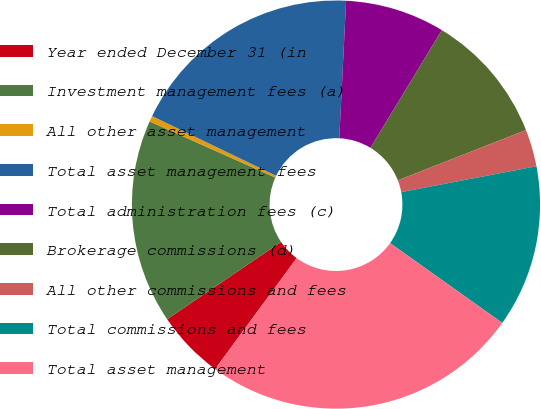<chart> <loc_0><loc_0><loc_500><loc_500><pie_chart><fcel>Year ended December 31 (in<fcel>Investment management fees (a)<fcel>All other asset management<fcel>Total asset management fees<fcel>Total administration fees (c)<fcel>Brokerage commissions (d)<fcel>All other commissions and fees<fcel>Total commissions and fees<fcel>Total asset management<nl><fcel>5.42%<fcel>16.17%<fcel>0.46%<fcel>18.65%<fcel>7.89%<fcel>10.37%<fcel>2.94%<fcel>12.85%<fcel>25.24%<nl></chart> 